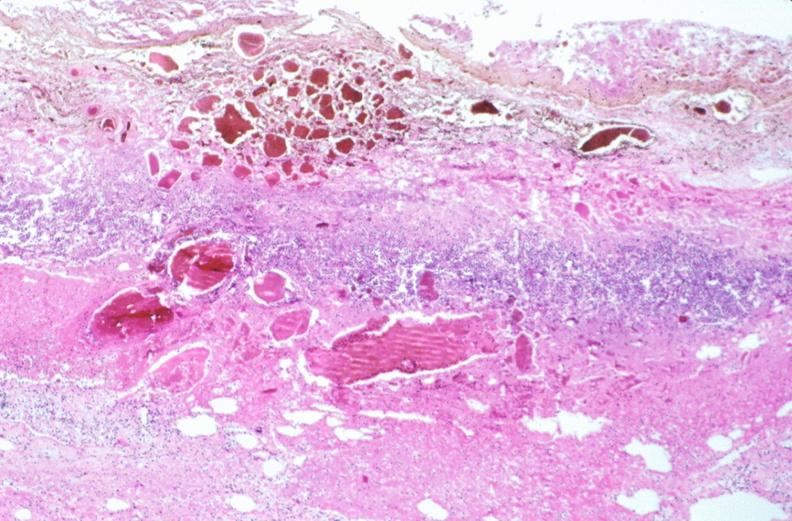what is stomach , necrotizing esophagitis and gastritis , sulfuric acid ingested?
Answer the question using a single word or phrase. As suicide attempt 